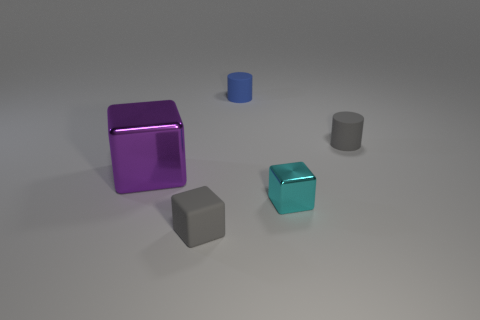What color is the small thing that is made of the same material as the big purple block?
Your answer should be compact. Cyan. Are there fewer small things to the left of the purple object than gray cylinders?
Your response must be concise. Yes. How big is the block that is right of the rubber thing in front of the small gray rubber object that is behind the small gray rubber block?
Provide a short and direct response. Small. Do the big thing that is to the left of the tiny cyan shiny block and the tiny cyan thing have the same material?
Make the answer very short. Yes. Is there anything else that has the same shape as the purple thing?
Offer a terse response. Yes. What number of things are large cyan metallic things or small objects?
Ensure brevity in your answer.  4. There is a purple metallic object that is the same shape as the cyan thing; what size is it?
Your response must be concise. Large. Are there any other things that have the same size as the purple shiny cube?
Your response must be concise. No. How many other things are there of the same color as the tiny shiny thing?
Provide a short and direct response. 0. What number of cubes are either large things or tiny cyan things?
Provide a short and direct response. 2. 